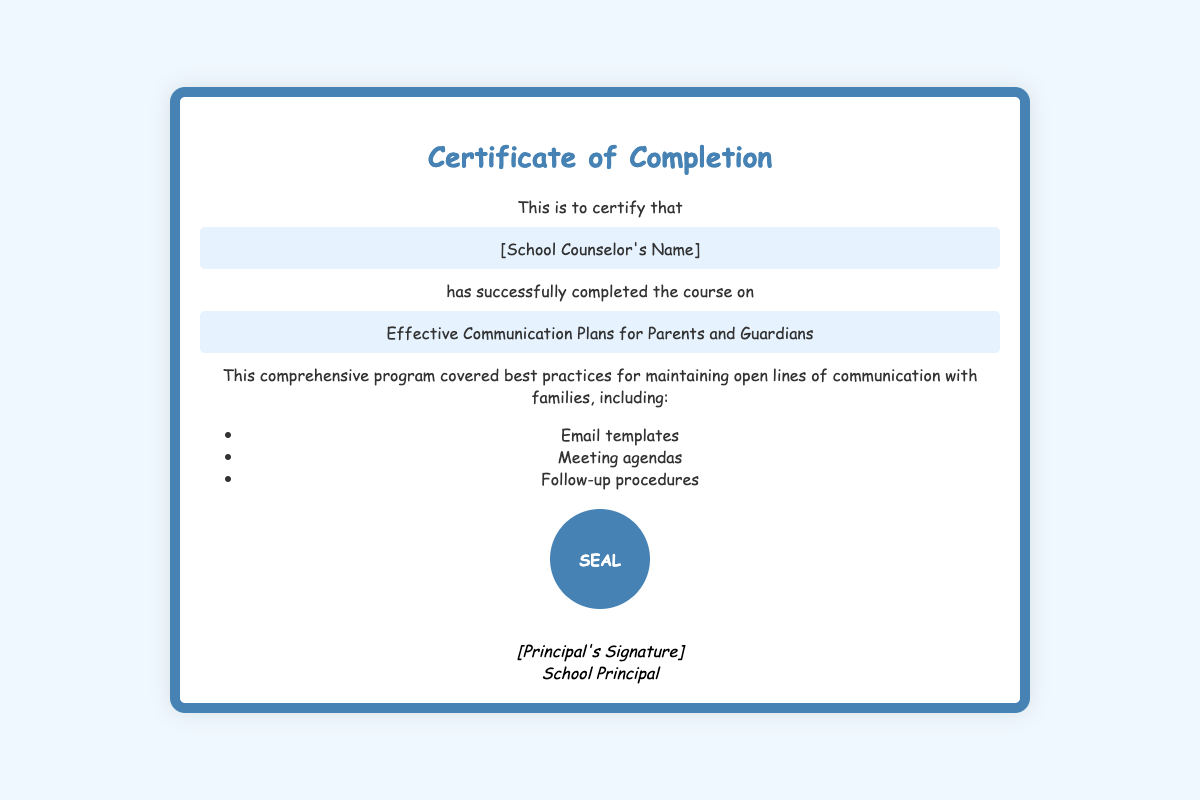What is the title of the course? The title of the course is mentioned directly in the document, which is "Effective Communication Plans for Parents and Guardians."
Answer: Effective Communication Plans for Parents and Guardians Who is receiving the certificate? The recipient is identified in the document as "[School Counselor's Name]."
Answer: [School Counselor's Name] What color is the background of the certificate? The background color of the certificate is stated in the document as "#f0f8ff."
Answer: #f0f8ff What type of plans does the course focus on? The course focuses on communication plans as indicated in the title of the course.
Answer: communication plans What are two components covered in the course? The course components are listed in a bullet point format in the document, including "Email templates" and "Meeting agendas."
Answer: Email templates, Meeting agendas Who signs the certificate? The certificate is signed by the individual identified as the "School Principal," which indicates their authority.
Answer: School Principal What shape is the seal on the certificate? The shape of the seal is mentioned in the document as "circle" or "circular."
Answer: circle What is the design style of the text on the certificate? The design style of the text is mentioned as "Comic Sans MS," which reflects an informal style.
Answer: Comic Sans MS What is the border color of the certificate? The border color is specifically highlighted in the document as "#4682b4."
Answer: #4682b4 